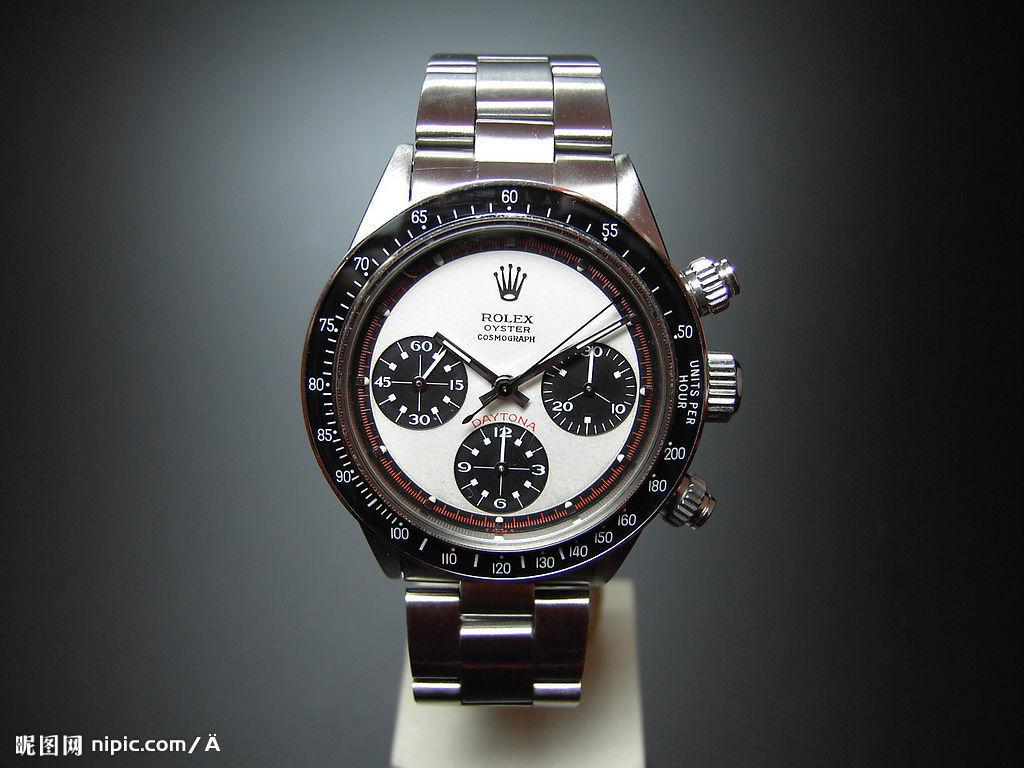<image>
Summarize the visual content of the image. A Rolex Oyster Cosmograph watch is displayed against a gray background in this nipic.com photo. 